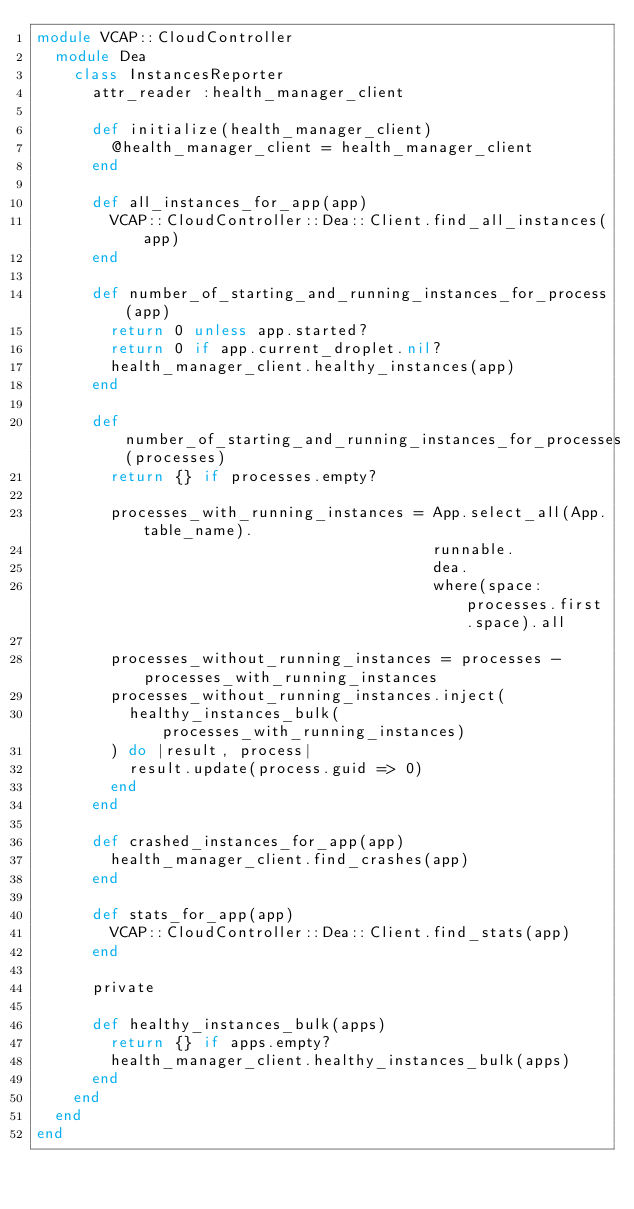<code> <loc_0><loc_0><loc_500><loc_500><_Ruby_>module VCAP::CloudController
  module Dea
    class InstancesReporter
      attr_reader :health_manager_client

      def initialize(health_manager_client)
        @health_manager_client = health_manager_client
      end

      def all_instances_for_app(app)
        VCAP::CloudController::Dea::Client.find_all_instances(app)
      end

      def number_of_starting_and_running_instances_for_process(app)
        return 0 unless app.started?
        return 0 if app.current_droplet.nil?
        health_manager_client.healthy_instances(app)
      end

      def number_of_starting_and_running_instances_for_processes(processes)
        return {} if processes.empty?

        processes_with_running_instances = App.select_all(App.table_name).
                                           runnable.
                                           dea.
                                           where(space: processes.first.space).all

        processes_without_running_instances = processes - processes_with_running_instances
        processes_without_running_instances.inject(
          healthy_instances_bulk(processes_with_running_instances)
        ) do |result, process|
          result.update(process.guid => 0)
        end
      end

      def crashed_instances_for_app(app)
        health_manager_client.find_crashes(app)
      end

      def stats_for_app(app)
        VCAP::CloudController::Dea::Client.find_stats(app)
      end

      private

      def healthy_instances_bulk(apps)
        return {} if apps.empty?
        health_manager_client.healthy_instances_bulk(apps)
      end
    end
  end
end
</code> 